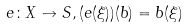Convert formula to latex. <formula><loc_0><loc_0><loc_500><loc_500>e \colon X \to S , ( e ( \xi ) ) ( b ) = b ( \xi )</formula> 